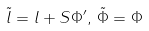Convert formula to latex. <formula><loc_0><loc_0><loc_500><loc_500>\tilde { l } = { l } + S { \Phi } ^ { \prime } , \, \tilde { \Phi } = { \Phi }</formula> 